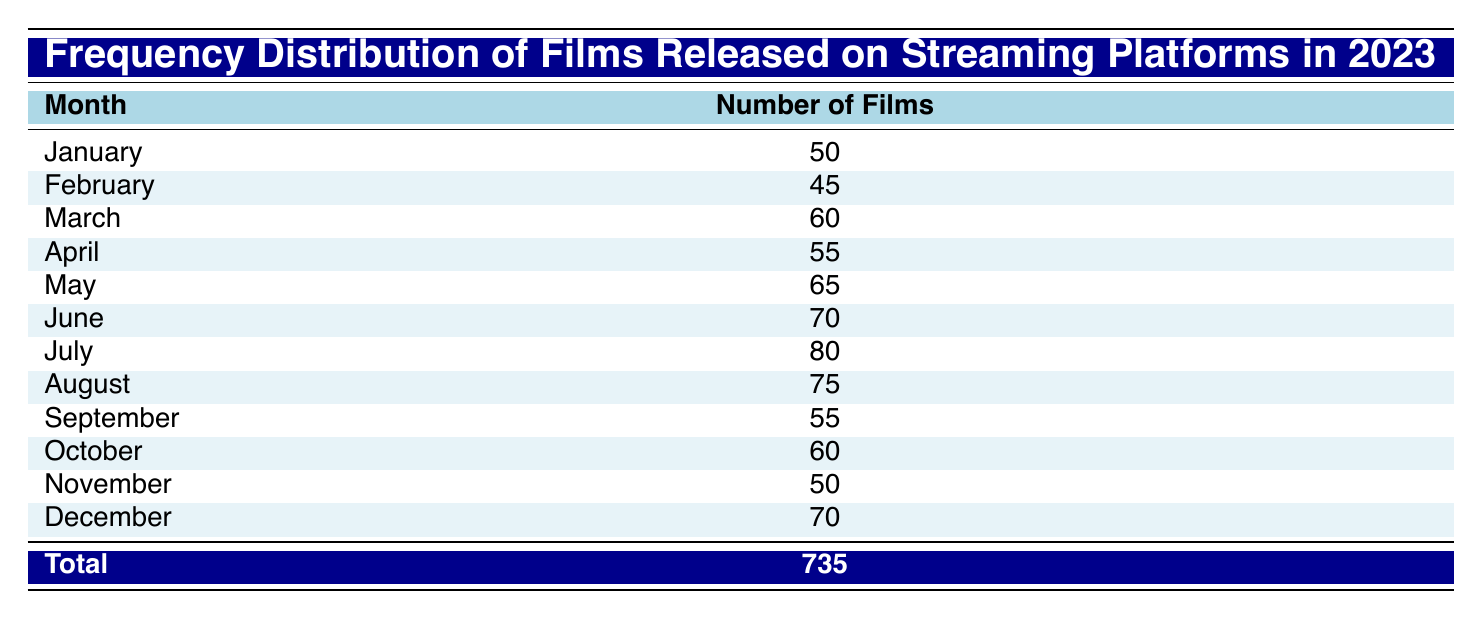What month had the highest number of films released? July has the highest number with 80 films released. This can be determined by looking for the month with the maximum value in the "Number of Films" column.
Answer: July What is the average number of films released each month? First, sum all the films released from January to December: (50 + 45 + 60 + 55 + 65 + 70 + 80 + 75 + 55 + 60 + 50 + 70) = 735. There are 12 months, so divide 735 by 12, which equals 61.25.
Answer: 61.25 Did more films get released in August than in June? Comparing the numbers, August has 75 films while June has 70. Since 75 is greater than 70, the answer is yes.
Answer: Yes What is the difference in the number of films released between the month with the least and the month with the most films? The month with the least films is February with 45 films, and the month with the most is July with 80 films. The difference is 80 - 45 = 35.
Answer: 35 Was the total number of films released in the first half of the year greater than in the last half? The total for January to June is 50 + 45 + 60 + 55 + 65 + 70 = 405. For July to December, the total is 80 + 75 + 55 + 60 + 50 + 70 = 390. Since 405 is greater than 390, the answer is yes.
Answer: Yes What are the two months that had the same number of films released? November and January both had 50 films released. By comparing the values in the table, both months can be identified as having the same count.
Answer: November and January 